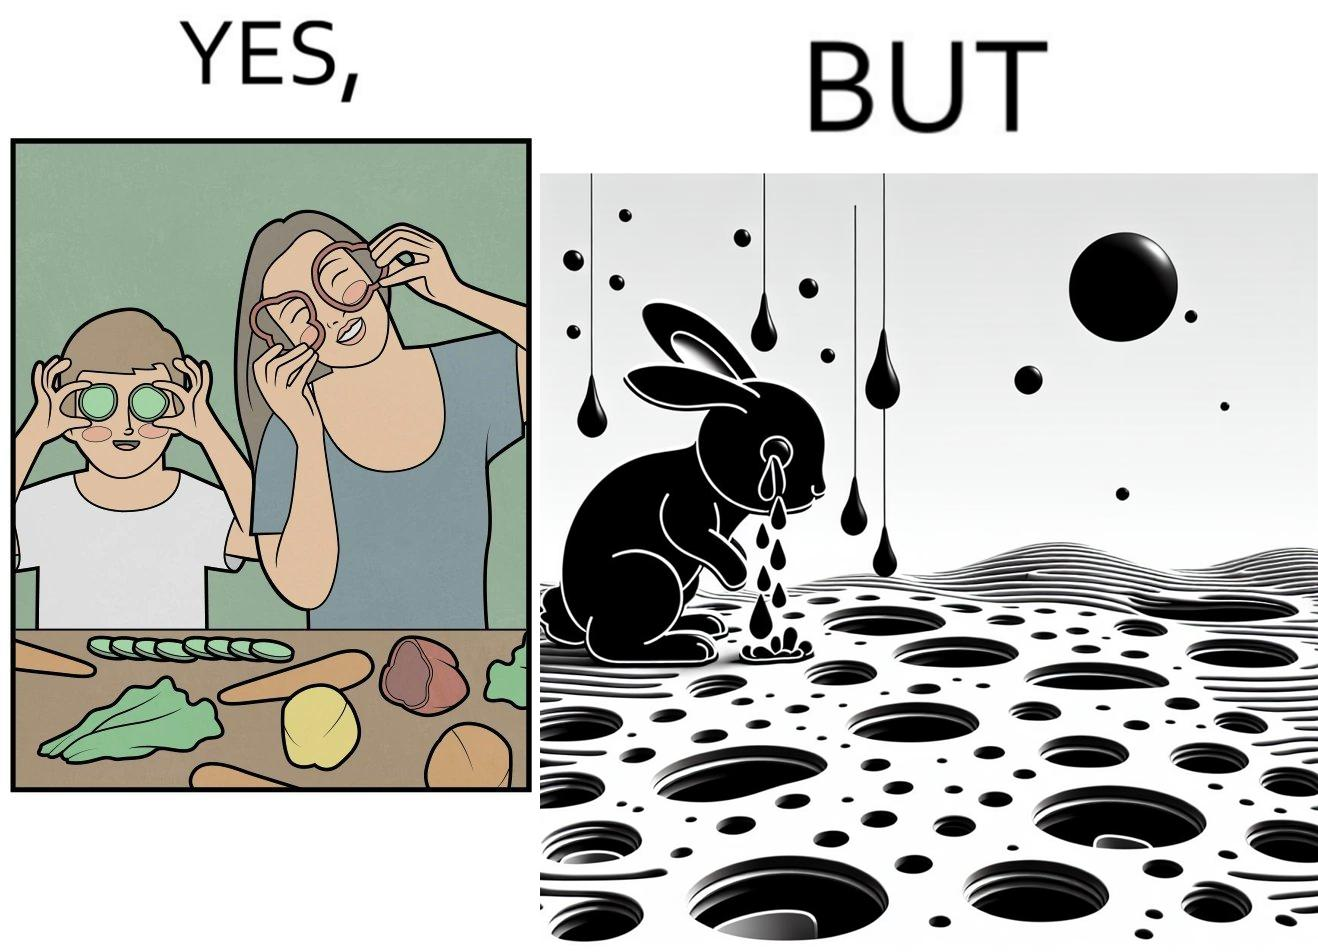Describe the content of this image. The images are ironic since they show how on one hand humans choose to play with and waste foods like vegetables while the animals are unable to eat enough food and end up starving due to lack of food 